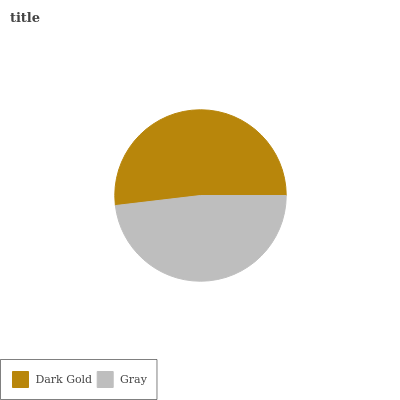Is Gray the minimum?
Answer yes or no. Yes. Is Dark Gold the maximum?
Answer yes or no. Yes. Is Gray the maximum?
Answer yes or no. No. Is Dark Gold greater than Gray?
Answer yes or no. Yes. Is Gray less than Dark Gold?
Answer yes or no. Yes. Is Gray greater than Dark Gold?
Answer yes or no. No. Is Dark Gold less than Gray?
Answer yes or no. No. Is Dark Gold the high median?
Answer yes or no. Yes. Is Gray the low median?
Answer yes or no. Yes. Is Gray the high median?
Answer yes or no. No. Is Dark Gold the low median?
Answer yes or no. No. 